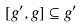Convert formula to latex. <formula><loc_0><loc_0><loc_500><loc_500>[ g ^ { \prime } , g ] \subseteq g ^ { \prime }</formula> 